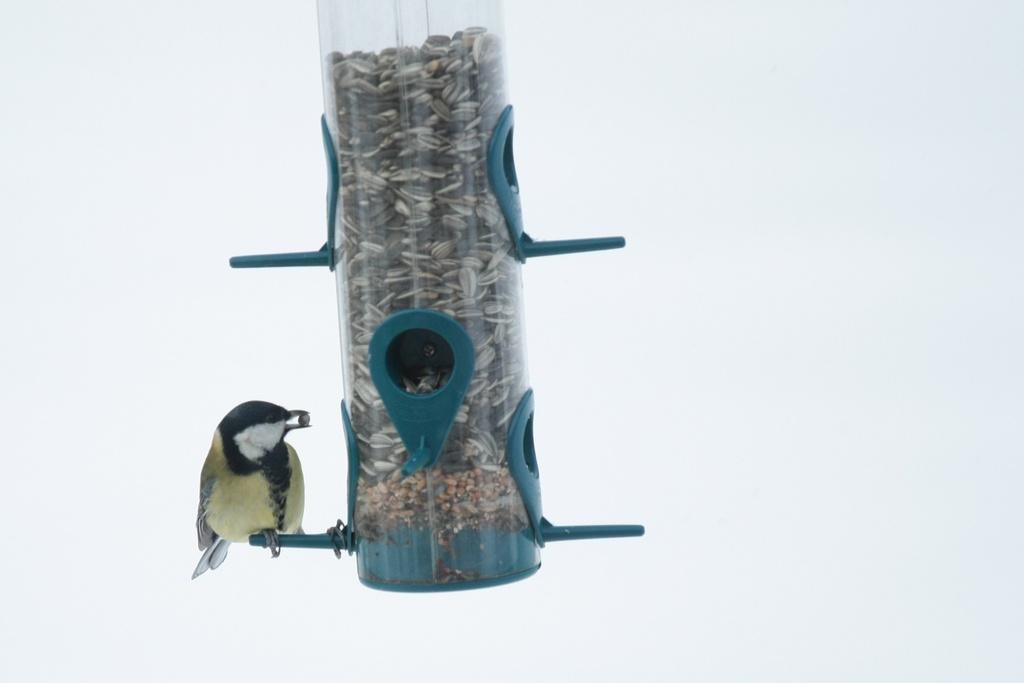Describe this image in one or two sentences. In this image there is a bird standing on an upside down on the thistle tube feeder 